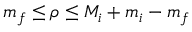<formula> <loc_0><loc_0><loc_500><loc_500>m _ { f } \leq \rho \leq M _ { i } + m _ { i } - m _ { f }</formula> 